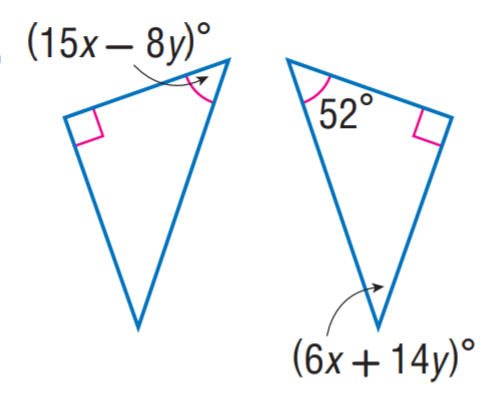Question: Find y.
Choices:
A. 1
B. 2
C. 3
D. 4
Answer with the letter. Answer: A Question: Find x.
Choices:
A. 1
B. 2
C. 3
D. 4
Answer with the letter. Answer: D 